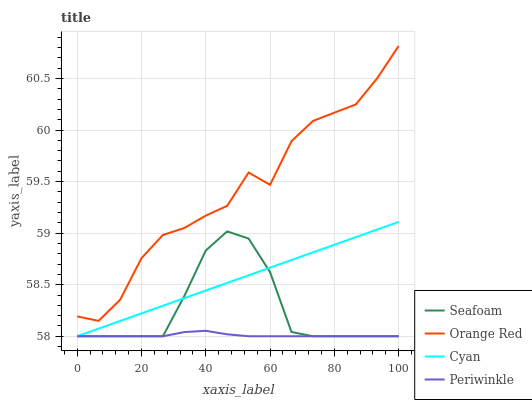Does Periwinkle have the minimum area under the curve?
Answer yes or no. Yes. Does Orange Red have the maximum area under the curve?
Answer yes or no. Yes. Does Seafoam have the minimum area under the curve?
Answer yes or no. No. Does Seafoam have the maximum area under the curve?
Answer yes or no. No. Is Cyan the smoothest?
Answer yes or no. Yes. Is Orange Red the roughest?
Answer yes or no. Yes. Is Periwinkle the smoothest?
Answer yes or no. No. Is Periwinkle the roughest?
Answer yes or no. No. Does Orange Red have the lowest value?
Answer yes or no. No. Does Orange Red have the highest value?
Answer yes or no. Yes. Does Seafoam have the highest value?
Answer yes or no. No. Is Periwinkle less than Orange Red?
Answer yes or no. Yes. Is Orange Red greater than Periwinkle?
Answer yes or no. Yes. Does Periwinkle intersect Seafoam?
Answer yes or no. Yes. Is Periwinkle less than Seafoam?
Answer yes or no. No. Is Periwinkle greater than Seafoam?
Answer yes or no. No. Does Periwinkle intersect Orange Red?
Answer yes or no. No. 